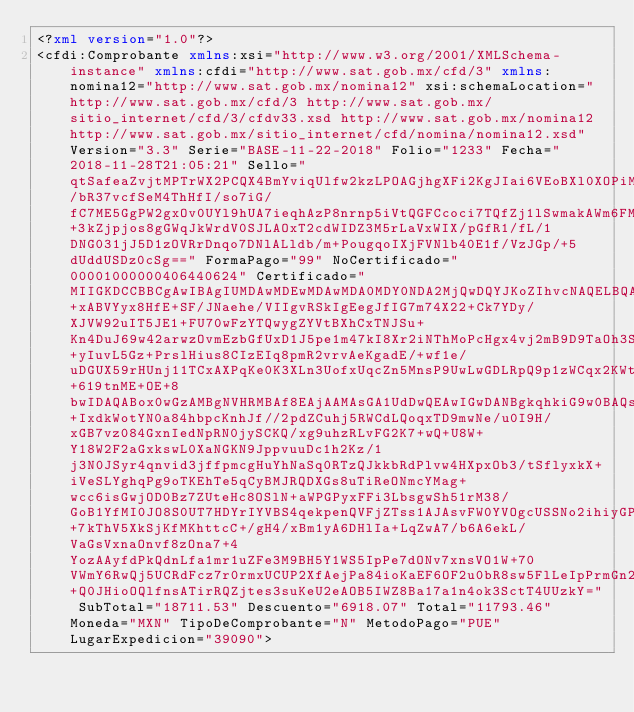Convert code to text. <code><loc_0><loc_0><loc_500><loc_500><_XML_><?xml version="1.0"?>
<cfdi:Comprobante xmlns:xsi="http://www.w3.org/2001/XMLSchema-instance" xmlns:cfdi="http://www.sat.gob.mx/cfd/3" xmlns:nomina12="http://www.sat.gob.mx/nomina12" xsi:schemaLocation="http://www.sat.gob.mx/cfd/3 http://www.sat.gob.mx/sitio_internet/cfd/3/cfdv33.xsd http://www.sat.gob.mx/nomina12 http://www.sat.gob.mx/sitio_internet/cfd/nomina/nomina12.xsd" Version="3.3" Serie="BASE-11-22-2018" Folio="1233" Fecha="2018-11-28T21:05:21" Sello="qtSafeaZvjtMPTrWX2PCQX4BmYviqUlfw2kzLPOAGjhgXFi2KgJIai6VEoBXl0XOPiMdBp8IxrtvF4cH8i1sp3aKftGyDVHLvMrxnaQfqV9zIS9U03gOaK/bR37vcfSeM4ThHfI/so7iG/fC7ME5GgPW2gxOv0UYl9hUA7ieqhAzP8nrnp5iVtQGFCcoci7TQfZj1lSwmakAWm6FM9fFW+3kZjpjos8gGWqJkWrdV0SJLAOxT2cdWIDZ3M5rLaVxWIX/pGfR1/fL/1DNG031jJ5D1zOVRrDnqo7DNlALldb/m+PougqoIXjFVNlb40E1f/VzJGp/+5dUddUSDz0cSg==" FormaPago="99" NoCertificado="00001000000406440624" Certificado="MIIGKDCCBBCgAwIBAgIUMDAwMDEwMDAwMDA0MDY0NDA2MjQwDQYJKoZIhvcNAQELBQAwggGyMTgwNgYDVQQDDC9BLkMuIGRlbCBTZXJ2aWNpbyBkZSBBZG1pbmlzdHJhY2nDs24gVHJpYnV0YXJpYTEvMC0GA1UECgwmU2VydmljaW8gZGUgQWRtaW5pc3RyYWNpw7NuIFRyaWJ1dGFyaWExODA2BgNVBAsML0FkbWluaXN0cmFjacOzbiBkZSBTZWd1cmlkYWQgZGUgbGEgSW5mb3JtYWNpw7NuMR8wHQYJKoZIhvcNAQkBFhBhY29kc0BzYXQuZ29iLm14MSYwJAYDVQQJDB1Bdi4gSGlkYWxnbyA3NywgQ29sLiBHdWVycmVybzEOMAwGA1UEEQwFMDYzMDAxCzAJBgNVBAYTAk1YMRkwFwYDVQQIDBBEaXN0cml0byBGZWRlcmFsMRQwEgYDVQQHDAtDdWF1aHTDqW1vYzEVMBMGA1UELRMMU0FUOTcwNzAxTk4zMV0wWwYJKoZIhvcNAQkCDE5SZXNwb25zYWJsZTogQWRtaW5pc3RyYWNpw7NuIENlbnRyYWwgZGUgU2VydmljaW9zIFRyaWJ1dGFyaW9zIGFsIENvbnRyaWJ1eWVudGUwHhcNMTcwNjA2MTc1MDU3WhcNMjEwNjA2MTc1MDU3WjCByDElMCMGA1UEAxMcU0VSVklDSU9TIEVTVEFUQUxFUyBERSBTQUxVRDElMCMGA1UEKRMcU0VSVklDSU9TIEVTVEFUQUxFUyBERSBTQUxVRDElMCMGA1UEChMcU0VSVklDSU9TIEVTVEFUQUxFUyBERSBTQUxVRDElMCMGA1UELRMcU0VTODcwNDAxVFg4IC8gUEVQQzUwMTEwNDhMNDEeMBwGA1UEBRMVIC8gUEVQQzUwMTEwNEhHUlhOUjA3MQowCAYDVQQLEwExMIIBIjANBgkqhkiG9w0BAQEFAAOCAQ8AMIIBCgKCAQEAtAhCkka+xABVYyx8HfE+SF/JNaehe/VIIgvRSkIgEegJfIG7m74X22+Ck7YDy/XJVW92uIT5JE1+FU70wFzYTQwygZYVtBXhCxTNJSu+Kn4DuJ69w42arwzOvmEzbGfUxD1J5pe1m47kI8Xr2iNThMoPcHgx4vj2mB9D9TaOh3SadqMiHzJO9nNFjDowcFZMBiGFu1HyeKuGWJQ+yIuvL5Gz+PrslHius8CIzEIq8pmR2vrvAeKgadE/+wf1e/uDGUX59rHUnj11TCxAXPqKe0K3XLn3UofxUqcZn5MnsP9UwLwGDLRpQ9p1zWCqx2KWtDb2n8R+619tnME+OE+8bwIDAQABox0wGzAMBgNVHRMBAf8EAjAAMAsGA1UdDwQEAwIGwDANBgkqhkiG9w0BAQsFAAOCAgEAcbZrTdkJUbP7wRMV8XDiHU462DO2vJq6CwzD74yiPjqKZZ+IxdkWotYN0a84hbpcKnhJf//2pdZCuhj5RWCdLQoqxTD9mwNe/u0I9H/xGB7vz084GxnIedNpRN0jySCKQ/xg9uhzRLvFG2K7+wQ+U8W+Y18W2F2aGxkswL0XaNGKN9JppvuuDc1h2Kz/1j3N0JSyr4qnvid3jffpmcgHuYhNaSq0RTzQJkkbRdPlvw4HXpxOb3/tSflyxkX+iVeSLYghqPg9oTKEhTe5qCyBMJRQDXGs8uTiReONmcYMag+wcc6isGwjOD0Bz7ZUteHc8OSlN+aWPGPyxFFi3LbsgwSh51rM38/GoB1YfMI0JO8S0UT7HDYrIYVBS4qekpenQVFjZTss1AJAsvFW0YVOgcUSSNo2ihiyGP+7kThV5XkSjKfMKhttcC+/gH4/xBm1yA6DHlIa+LqZwA7/b6A6ekL/VaGsVxnaOnvf8zOna7+4YozAAyfdPkQdnLfa1mr1uZFe3M9BH5Y1WS5IpPe7dONv7xnsVO1W+70VWmY6RwQj5UCRdFcz7r0rmxUCUP2XfAejPa84ioKaEF6OF2u0bR8sw5FlLeIpPrmGn2qeshKzWm+Q0JHioOQlfnsATirRQZjtes3suKeU2eAOB5IWZ8Ba17a1n4ok3SctT4UUzkY=" SubTotal="18711.53" Descuento="6918.07" Total="11793.46" Moneda="MXN" TipoDeComprobante="N" MetodoPago="PUE" LugarExpedicion="39090"></code> 